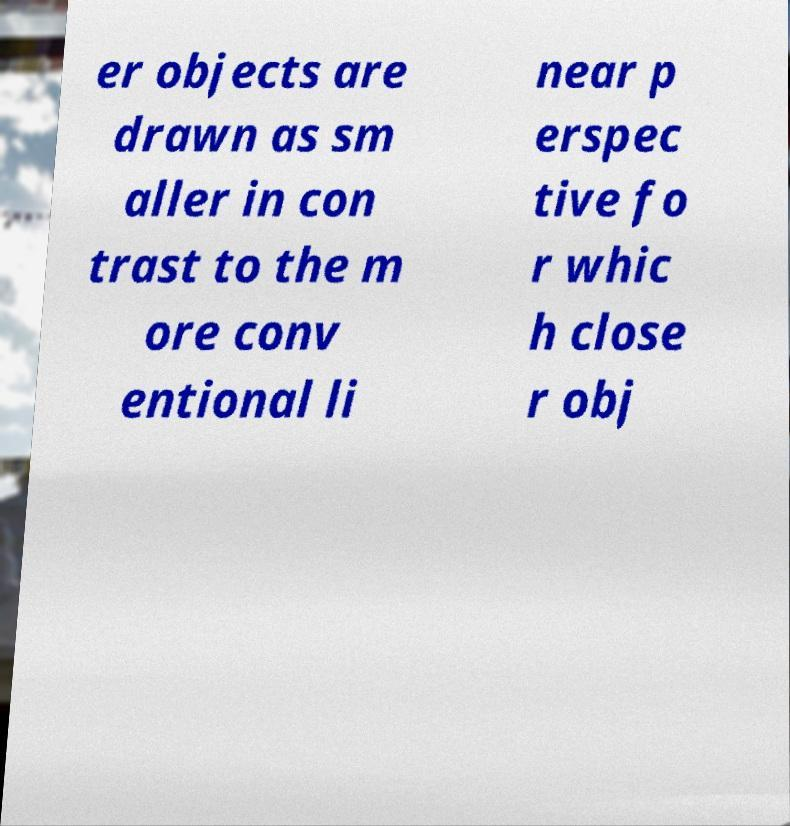Could you extract and type out the text from this image? er objects are drawn as sm aller in con trast to the m ore conv entional li near p erspec tive fo r whic h close r obj 